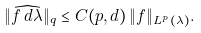Convert formula to latex. <formula><loc_0><loc_0><loc_500><loc_500>\| \widehat { f \, d \lambda } \| _ { q } \leq C ( p , d ) \, \| f \| _ { L ^ { p } ( \lambda ) } .</formula> 